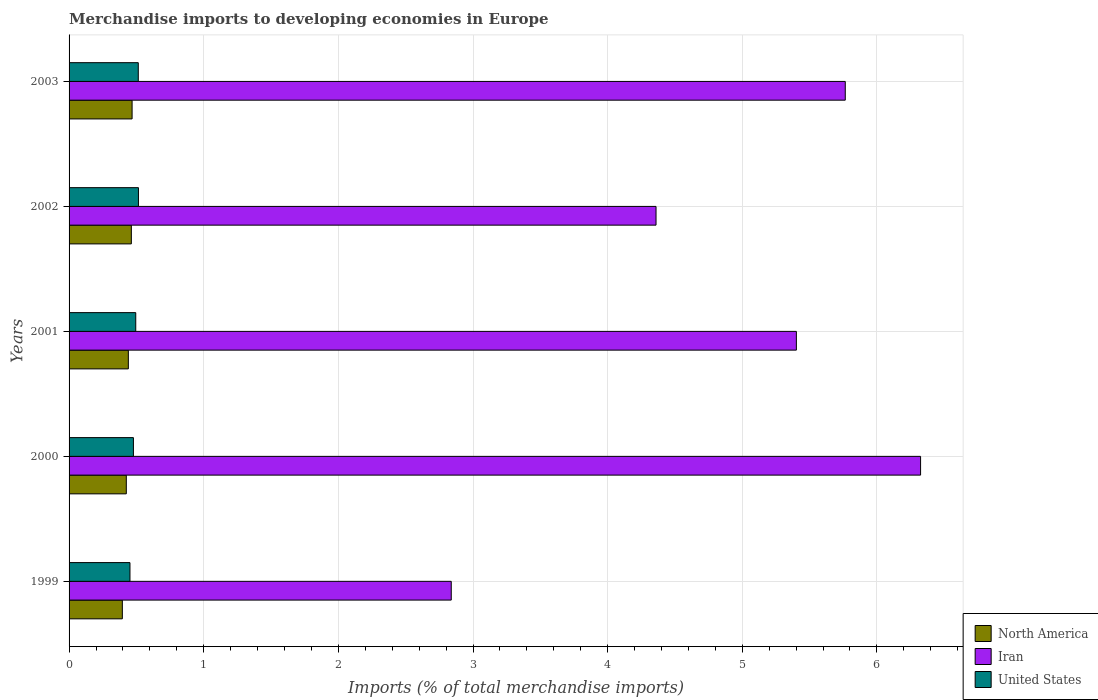How many groups of bars are there?
Offer a terse response. 5. Are the number of bars per tick equal to the number of legend labels?
Keep it short and to the point. Yes. In how many cases, is the number of bars for a given year not equal to the number of legend labels?
Keep it short and to the point. 0. What is the percentage total merchandise imports in North America in 2002?
Give a very brief answer. 0.46. Across all years, what is the maximum percentage total merchandise imports in Iran?
Provide a succinct answer. 6.32. Across all years, what is the minimum percentage total merchandise imports in North America?
Give a very brief answer. 0.4. In which year was the percentage total merchandise imports in Iran maximum?
Ensure brevity in your answer.  2000. In which year was the percentage total merchandise imports in North America minimum?
Provide a short and direct response. 1999. What is the total percentage total merchandise imports in United States in the graph?
Your response must be concise. 2.45. What is the difference between the percentage total merchandise imports in United States in 2002 and that in 2003?
Ensure brevity in your answer.  0. What is the difference between the percentage total merchandise imports in United States in 2003 and the percentage total merchandise imports in North America in 2002?
Provide a succinct answer. 0.05. What is the average percentage total merchandise imports in United States per year?
Provide a succinct answer. 0.49. In the year 2001, what is the difference between the percentage total merchandise imports in Iran and percentage total merchandise imports in North America?
Your response must be concise. 4.96. In how many years, is the percentage total merchandise imports in Iran greater than 2.8 %?
Provide a succinct answer. 5. What is the ratio of the percentage total merchandise imports in North America in 1999 to that in 2000?
Offer a very short reply. 0.93. Is the difference between the percentage total merchandise imports in Iran in 1999 and 2001 greater than the difference between the percentage total merchandise imports in North America in 1999 and 2001?
Your response must be concise. No. What is the difference between the highest and the second highest percentage total merchandise imports in North America?
Make the answer very short. 0.01. What is the difference between the highest and the lowest percentage total merchandise imports in North America?
Keep it short and to the point. 0.07. In how many years, is the percentage total merchandise imports in United States greater than the average percentage total merchandise imports in United States taken over all years?
Your answer should be very brief. 3. What does the 1st bar from the bottom in 1999 represents?
Provide a succinct answer. North America. Is it the case that in every year, the sum of the percentage total merchandise imports in North America and percentage total merchandise imports in Iran is greater than the percentage total merchandise imports in United States?
Your response must be concise. Yes. How many bars are there?
Your answer should be compact. 15. Are all the bars in the graph horizontal?
Provide a succinct answer. Yes. How many years are there in the graph?
Ensure brevity in your answer.  5. Does the graph contain any zero values?
Offer a terse response. No. Does the graph contain grids?
Provide a succinct answer. Yes. Where does the legend appear in the graph?
Make the answer very short. Bottom right. What is the title of the graph?
Your response must be concise. Merchandise imports to developing economies in Europe. What is the label or title of the X-axis?
Give a very brief answer. Imports (% of total merchandise imports). What is the Imports (% of total merchandise imports) of North America in 1999?
Keep it short and to the point. 0.4. What is the Imports (% of total merchandise imports) in Iran in 1999?
Give a very brief answer. 2.84. What is the Imports (% of total merchandise imports) of United States in 1999?
Offer a terse response. 0.45. What is the Imports (% of total merchandise imports) of North America in 2000?
Offer a very short reply. 0.43. What is the Imports (% of total merchandise imports) of Iran in 2000?
Your answer should be very brief. 6.32. What is the Imports (% of total merchandise imports) in United States in 2000?
Your response must be concise. 0.48. What is the Imports (% of total merchandise imports) in North America in 2001?
Make the answer very short. 0.44. What is the Imports (% of total merchandise imports) of Iran in 2001?
Provide a succinct answer. 5.4. What is the Imports (% of total merchandise imports) in United States in 2001?
Your answer should be compact. 0.5. What is the Imports (% of total merchandise imports) in North America in 2002?
Your answer should be compact. 0.46. What is the Imports (% of total merchandise imports) in Iran in 2002?
Give a very brief answer. 4.36. What is the Imports (% of total merchandise imports) in United States in 2002?
Provide a succinct answer. 0.52. What is the Imports (% of total merchandise imports) of North America in 2003?
Provide a succinct answer. 0.47. What is the Imports (% of total merchandise imports) in Iran in 2003?
Provide a short and direct response. 5.76. What is the Imports (% of total merchandise imports) in United States in 2003?
Provide a succinct answer. 0.51. Across all years, what is the maximum Imports (% of total merchandise imports) in North America?
Make the answer very short. 0.47. Across all years, what is the maximum Imports (% of total merchandise imports) in Iran?
Keep it short and to the point. 6.32. Across all years, what is the maximum Imports (% of total merchandise imports) of United States?
Offer a very short reply. 0.52. Across all years, what is the minimum Imports (% of total merchandise imports) of North America?
Offer a terse response. 0.4. Across all years, what is the minimum Imports (% of total merchandise imports) of Iran?
Your answer should be very brief. 2.84. Across all years, what is the minimum Imports (% of total merchandise imports) in United States?
Your answer should be compact. 0.45. What is the total Imports (% of total merchandise imports) in North America in the graph?
Your answer should be very brief. 2.19. What is the total Imports (% of total merchandise imports) of Iran in the graph?
Keep it short and to the point. 24.69. What is the total Imports (% of total merchandise imports) in United States in the graph?
Keep it short and to the point. 2.45. What is the difference between the Imports (% of total merchandise imports) in North America in 1999 and that in 2000?
Make the answer very short. -0.03. What is the difference between the Imports (% of total merchandise imports) of Iran in 1999 and that in 2000?
Your answer should be very brief. -3.49. What is the difference between the Imports (% of total merchandise imports) of United States in 1999 and that in 2000?
Offer a terse response. -0.03. What is the difference between the Imports (% of total merchandise imports) in North America in 1999 and that in 2001?
Keep it short and to the point. -0.04. What is the difference between the Imports (% of total merchandise imports) in Iran in 1999 and that in 2001?
Keep it short and to the point. -2.56. What is the difference between the Imports (% of total merchandise imports) of United States in 1999 and that in 2001?
Your answer should be very brief. -0.04. What is the difference between the Imports (% of total merchandise imports) of North America in 1999 and that in 2002?
Your answer should be very brief. -0.07. What is the difference between the Imports (% of total merchandise imports) in Iran in 1999 and that in 2002?
Keep it short and to the point. -1.52. What is the difference between the Imports (% of total merchandise imports) of United States in 1999 and that in 2002?
Provide a short and direct response. -0.06. What is the difference between the Imports (% of total merchandise imports) of North America in 1999 and that in 2003?
Provide a succinct answer. -0.07. What is the difference between the Imports (% of total merchandise imports) of Iran in 1999 and that in 2003?
Provide a short and direct response. -2.93. What is the difference between the Imports (% of total merchandise imports) of United States in 1999 and that in 2003?
Offer a terse response. -0.06. What is the difference between the Imports (% of total merchandise imports) of North America in 2000 and that in 2001?
Ensure brevity in your answer.  -0.02. What is the difference between the Imports (% of total merchandise imports) of Iran in 2000 and that in 2001?
Give a very brief answer. 0.92. What is the difference between the Imports (% of total merchandise imports) of United States in 2000 and that in 2001?
Ensure brevity in your answer.  -0.02. What is the difference between the Imports (% of total merchandise imports) of North America in 2000 and that in 2002?
Your response must be concise. -0.04. What is the difference between the Imports (% of total merchandise imports) in Iran in 2000 and that in 2002?
Make the answer very short. 1.96. What is the difference between the Imports (% of total merchandise imports) in United States in 2000 and that in 2002?
Provide a short and direct response. -0.04. What is the difference between the Imports (% of total merchandise imports) of North America in 2000 and that in 2003?
Keep it short and to the point. -0.04. What is the difference between the Imports (% of total merchandise imports) of Iran in 2000 and that in 2003?
Your response must be concise. 0.56. What is the difference between the Imports (% of total merchandise imports) of United States in 2000 and that in 2003?
Provide a succinct answer. -0.04. What is the difference between the Imports (% of total merchandise imports) of North America in 2001 and that in 2002?
Provide a short and direct response. -0.02. What is the difference between the Imports (% of total merchandise imports) of Iran in 2001 and that in 2002?
Your answer should be very brief. 1.04. What is the difference between the Imports (% of total merchandise imports) of United States in 2001 and that in 2002?
Offer a terse response. -0.02. What is the difference between the Imports (% of total merchandise imports) of North America in 2001 and that in 2003?
Your response must be concise. -0.03. What is the difference between the Imports (% of total merchandise imports) of Iran in 2001 and that in 2003?
Offer a terse response. -0.36. What is the difference between the Imports (% of total merchandise imports) in United States in 2001 and that in 2003?
Provide a short and direct response. -0.02. What is the difference between the Imports (% of total merchandise imports) of North America in 2002 and that in 2003?
Make the answer very short. -0.01. What is the difference between the Imports (% of total merchandise imports) in Iran in 2002 and that in 2003?
Ensure brevity in your answer.  -1.41. What is the difference between the Imports (% of total merchandise imports) of United States in 2002 and that in 2003?
Make the answer very short. 0. What is the difference between the Imports (% of total merchandise imports) in North America in 1999 and the Imports (% of total merchandise imports) in Iran in 2000?
Make the answer very short. -5.93. What is the difference between the Imports (% of total merchandise imports) of North America in 1999 and the Imports (% of total merchandise imports) of United States in 2000?
Make the answer very short. -0.08. What is the difference between the Imports (% of total merchandise imports) in Iran in 1999 and the Imports (% of total merchandise imports) in United States in 2000?
Offer a very short reply. 2.36. What is the difference between the Imports (% of total merchandise imports) of North America in 1999 and the Imports (% of total merchandise imports) of Iran in 2001?
Make the answer very short. -5.01. What is the difference between the Imports (% of total merchandise imports) of North America in 1999 and the Imports (% of total merchandise imports) of United States in 2001?
Your response must be concise. -0.1. What is the difference between the Imports (% of total merchandise imports) of Iran in 1999 and the Imports (% of total merchandise imports) of United States in 2001?
Ensure brevity in your answer.  2.34. What is the difference between the Imports (% of total merchandise imports) of North America in 1999 and the Imports (% of total merchandise imports) of Iran in 2002?
Your answer should be compact. -3.96. What is the difference between the Imports (% of total merchandise imports) of North America in 1999 and the Imports (% of total merchandise imports) of United States in 2002?
Your response must be concise. -0.12. What is the difference between the Imports (% of total merchandise imports) of Iran in 1999 and the Imports (% of total merchandise imports) of United States in 2002?
Your answer should be very brief. 2.32. What is the difference between the Imports (% of total merchandise imports) in North America in 1999 and the Imports (% of total merchandise imports) in Iran in 2003?
Your response must be concise. -5.37. What is the difference between the Imports (% of total merchandise imports) of North America in 1999 and the Imports (% of total merchandise imports) of United States in 2003?
Provide a short and direct response. -0.12. What is the difference between the Imports (% of total merchandise imports) in Iran in 1999 and the Imports (% of total merchandise imports) in United States in 2003?
Make the answer very short. 2.32. What is the difference between the Imports (% of total merchandise imports) of North America in 2000 and the Imports (% of total merchandise imports) of Iran in 2001?
Make the answer very short. -4.98. What is the difference between the Imports (% of total merchandise imports) in North America in 2000 and the Imports (% of total merchandise imports) in United States in 2001?
Keep it short and to the point. -0.07. What is the difference between the Imports (% of total merchandise imports) in Iran in 2000 and the Imports (% of total merchandise imports) in United States in 2001?
Your answer should be compact. 5.83. What is the difference between the Imports (% of total merchandise imports) in North America in 2000 and the Imports (% of total merchandise imports) in Iran in 2002?
Offer a very short reply. -3.93. What is the difference between the Imports (% of total merchandise imports) in North America in 2000 and the Imports (% of total merchandise imports) in United States in 2002?
Make the answer very short. -0.09. What is the difference between the Imports (% of total merchandise imports) of Iran in 2000 and the Imports (% of total merchandise imports) of United States in 2002?
Keep it short and to the point. 5.81. What is the difference between the Imports (% of total merchandise imports) in North America in 2000 and the Imports (% of total merchandise imports) in Iran in 2003?
Your response must be concise. -5.34. What is the difference between the Imports (% of total merchandise imports) of North America in 2000 and the Imports (% of total merchandise imports) of United States in 2003?
Your answer should be very brief. -0.09. What is the difference between the Imports (% of total merchandise imports) in Iran in 2000 and the Imports (% of total merchandise imports) in United States in 2003?
Your response must be concise. 5.81. What is the difference between the Imports (% of total merchandise imports) in North America in 2001 and the Imports (% of total merchandise imports) in Iran in 2002?
Offer a very short reply. -3.92. What is the difference between the Imports (% of total merchandise imports) in North America in 2001 and the Imports (% of total merchandise imports) in United States in 2002?
Provide a short and direct response. -0.07. What is the difference between the Imports (% of total merchandise imports) in Iran in 2001 and the Imports (% of total merchandise imports) in United States in 2002?
Your response must be concise. 4.89. What is the difference between the Imports (% of total merchandise imports) of North America in 2001 and the Imports (% of total merchandise imports) of Iran in 2003?
Offer a terse response. -5.32. What is the difference between the Imports (% of total merchandise imports) of North America in 2001 and the Imports (% of total merchandise imports) of United States in 2003?
Give a very brief answer. -0.07. What is the difference between the Imports (% of total merchandise imports) in Iran in 2001 and the Imports (% of total merchandise imports) in United States in 2003?
Offer a terse response. 4.89. What is the difference between the Imports (% of total merchandise imports) of North America in 2002 and the Imports (% of total merchandise imports) of Iran in 2003?
Provide a succinct answer. -5.3. What is the difference between the Imports (% of total merchandise imports) in North America in 2002 and the Imports (% of total merchandise imports) in United States in 2003?
Keep it short and to the point. -0.05. What is the difference between the Imports (% of total merchandise imports) of Iran in 2002 and the Imports (% of total merchandise imports) of United States in 2003?
Make the answer very short. 3.85. What is the average Imports (% of total merchandise imports) in North America per year?
Your answer should be compact. 0.44. What is the average Imports (% of total merchandise imports) of Iran per year?
Give a very brief answer. 4.94. What is the average Imports (% of total merchandise imports) of United States per year?
Keep it short and to the point. 0.49. In the year 1999, what is the difference between the Imports (% of total merchandise imports) of North America and Imports (% of total merchandise imports) of Iran?
Offer a very short reply. -2.44. In the year 1999, what is the difference between the Imports (% of total merchandise imports) in North America and Imports (% of total merchandise imports) in United States?
Your response must be concise. -0.06. In the year 1999, what is the difference between the Imports (% of total merchandise imports) in Iran and Imports (% of total merchandise imports) in United States?
Provide a short and direct response. 2.39. In the year 2000, what is the difference between the Imports (% of total merchandise imports) in North America and Imports (% of total merchandise imports) in Iran?
Provide a succinct answer. -5.9. In the year 2000, what is the difference between the Imports (% of total merchandise imports) in North America and Imports (% of total merchandise imports) in United States?
Give a very brief answer. -0.05. In the year 2000, what is the difference between the Imports (% of total merchandise imports) of Iran and Imports (% of total merchandise imports) of United States?
Give a very brief answer. 5.85. In the year 2001, what is the difference between the Imports (% of total merchandise imports) of North America and Imports (% of total merchandise imports) of Iran?
Ensure brevity in your answer.  -4.96. In the year 2001, what is the difference between the Imports (% of total merchandise imports) of North America and Imports (% of total merchandise imports) of United States?
Provide a succinct answer. -0.06. In the year 2001, what is the difference between the Imports (% of total merchandise imports) of Iran and Imports (% of total merchandise imports) of United States?
Make the answer very short. 4.91. In the year 2002, what is the difference between the Imports (% of total merchandise imports) in North America and Imports (% of total merchandise imports) in Iran?
Make the answer very short. -3.9. In the year 2002, what is the difference between the Imports (% of total merchandise imports) of North America and Imports (% of total merchandise imports) of United States?
Provide a short and direct response. -0.05. In the year 2002, what is the difference between the Imports (% of total merchandise imports) in Iran and Imports (% of total merchandise imports) in United States?
Ensure brevity in your answer.  3.84. In the year 2003, what is the difference between the Imports (% of total merchandise imports) in North America and Imports (% of total merchandise imports) in Iran?
Your answer should be very brief. -5.3. In the year 2003, what is the difference between the Imports (% of total merchandise imports) in North America and Imports (% of total merchandise imports) in United States?
Keep it short and to the point. -0.05. In the year 2003, what is the difference between the Imports (% of total merchandise imports) in Iran and Imports (% of total merchandise imports) in United States?
Offer a terse response. 5.25. What is the ratio of the Imports (% of total merchandise imports) in North America in 1999 to that in 2000?
Your answer should be very brief. 0.93. What is the ratio of the Imports (% of total merchandise imports) of Iran in 1999 to that in 2000?
Provide a short and direct response. 0.45. What is the ratio of the Imports (% of total merchandise imports) in United States in 1999 to that in 2000?
Offer a terse response. 0.95. What is the ratio of the Imports (% of total merchandise imports) in North America in 1999 to that in 2001?
Make the answer very short. 0.9. What is the ratio of the Imports (% of total merchandise imports) of Iran in 1999 to that in 2001?
Give a very brief answer. 0.53. What is the ratio of the Imports (% of total merchandise imports) of United States in 1999 to that in 2001?
Provide a succinct answer. 0.91. What is the ratio of the Imports (% of total merchandise imports) of North America in 1999 to that in 2002?
Ensure brevity in your answer.  0.86. What is the ratio of the Imports (% of total merchandise imports) in Iran in 1999 to that in 2002?
Make the answer very short. 0.65. What is the ratio of the Imports (% of total merchandise imports) in United States in 1999 to that in 2002?
Keep it short and to the point. 0.88. What is the ratio of the Imports (% of total merchandise imports) of North America in 1999 to that in 2003?
Offer a terse response. 0.85. What is the ratio of the Imports (% of total merchandise imports) in Iran in 1999 to that in 2003?
Give a very brief answer. 0.49. What is the ratio of the Imports (% of total merchandise imports) of United States in 1999 to that in 2003?
Keep it short and to the point. 0.88. What is the ratio of the Imports (% of total merchandise imports) in North America in 2000 to that in 2001?
Make the answer very short. 0.97. What is the ratio of the Imports (% of total merchandise imports) in Iran in 2000 to that in 2001?
Provide a succinct answer. 1.17. What is the ratio of the Imports (% of total merchandise imports) of United States in 2000 to that in 2001?
Your answer should be compact. 0.96. What is the ratio of the Imports (% of total merchandise imports) of North America in 2000 to that in 2002?
Provide a succinct answer. 0.92. What is the ratio of the Imports (% of total merchandise imports) of Iran in 2000 to that in 2002?
Provide a succinct answer. 1.45. What is the ratio of the Imports (% of total merchandise imports) of United States in 2000 to that in 2002?
Ensure brevity in your answer.  0.93. What is the ratio of the Imports (% of total merchandise imports) of North America in 2000 to that in 2003?
Your answer should be very brief. 0.91. What is the ratio of the Imports (% of total merchandise imports) of Iran in 2000 to that in 2003?
Provide a short and direct response. 1.1. What is the ratio of the Imports (% of total merchandise imports) of United States in 2000 to that in 2003?
Make the answer very short. 0.93. What is the ratio of the Imports (% of total merchandise imports) in North America in 2001 to that in 2002?
Provide a short and direct response. 0.95. What is the ratio of the Imports (% of total merchandise imports) in Iran in 2001 to that in 2002?
Provide a succinct answer. 1.24. What is the ratio of the Imports (% of total merchandise imports) in United States in 2001 to that in 2002?
Your response must be concise. 0.96. What is the ratio of the Imports (% of total merchandise imports) in North America in 2001 to that in 2003?
Your response must be concise. 0.94. What is the ratio of the Imports (% of total merchandise imports) in Iran in 2001 to that in 2003?
Your answer should be compact. 0.94. What is the ratio of the Imports (% of total merchandise imports) of United States in 2001 to that in 2003?
Give a very brief answer. 0.96. What is the ratio of the Imports (% of total merchandise imports) of North America in 2002 to that in 2003?
Give a very brief answer. 0.99. What is the ratio of the Imports (% of total merchandise imports) in Iran in 2002 to that in 2003?
Keep it short and to the point. 0.76. What is the ratio of the Imports (% of total merchandise imports) in United States in 2002 to that in 2003?
Ensure brevity in your answer.  1. What is the difference between the highest and the second highest Imports (% of total merchandise imports) in North America?
Provide a short and direct response. 0.01. What is the difference between the highest and the second highest Imports (% of total merchandise imports) of Iran?
Keep it short and to the point. 0.56. What is the difference between the highest and the second highest Imports (% of total merchandise imports) in United States?
Give a very brief answer. 0. What is the difference between the highest and the lowest Imports (% of total merchandise imports) in North America?
Give a very brief answer. 0.07. What is the difference between the highest and the lowest Imports (% of total merchandise imports) in Iran?
Offer a very short reply. 3.49. What is the difference between the highest and the lowest Imports (% of total merchandise imports) in United States?
Ensure brevity in your answer.  0.06. 